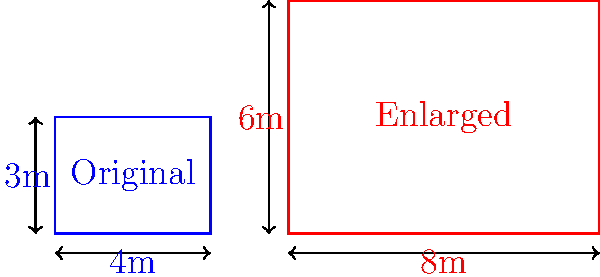As you plan to expand your boutique, you've created a scaled-up version of your current store's floor plan. The original boutique measures 4m by 3m, while the new retail space measures 8m by 6m. What is the scale factor used to enlarge the original floor plan? To find the scale factor, we need to compare the dimensions of the enlarged floor plan to the original:

1. Compare the widths:
   Enlarged width / Original width = 8m / 4m = 2

2. Compare the lengths:
   Enlarged length / Original length = 6m / 3m = 2

3. Verify that both ratios are the same:
   Width ratio = Length ratio = 2

The scale factor is consistent for both dimensions, which is necessary for a uniform enlargement.

Therefore, the scale factor used to enlarge the original floor plan is 2, meaning all dimensions of the original plan were multiplied by 2 to create the enlarged version.
Answer: 2 